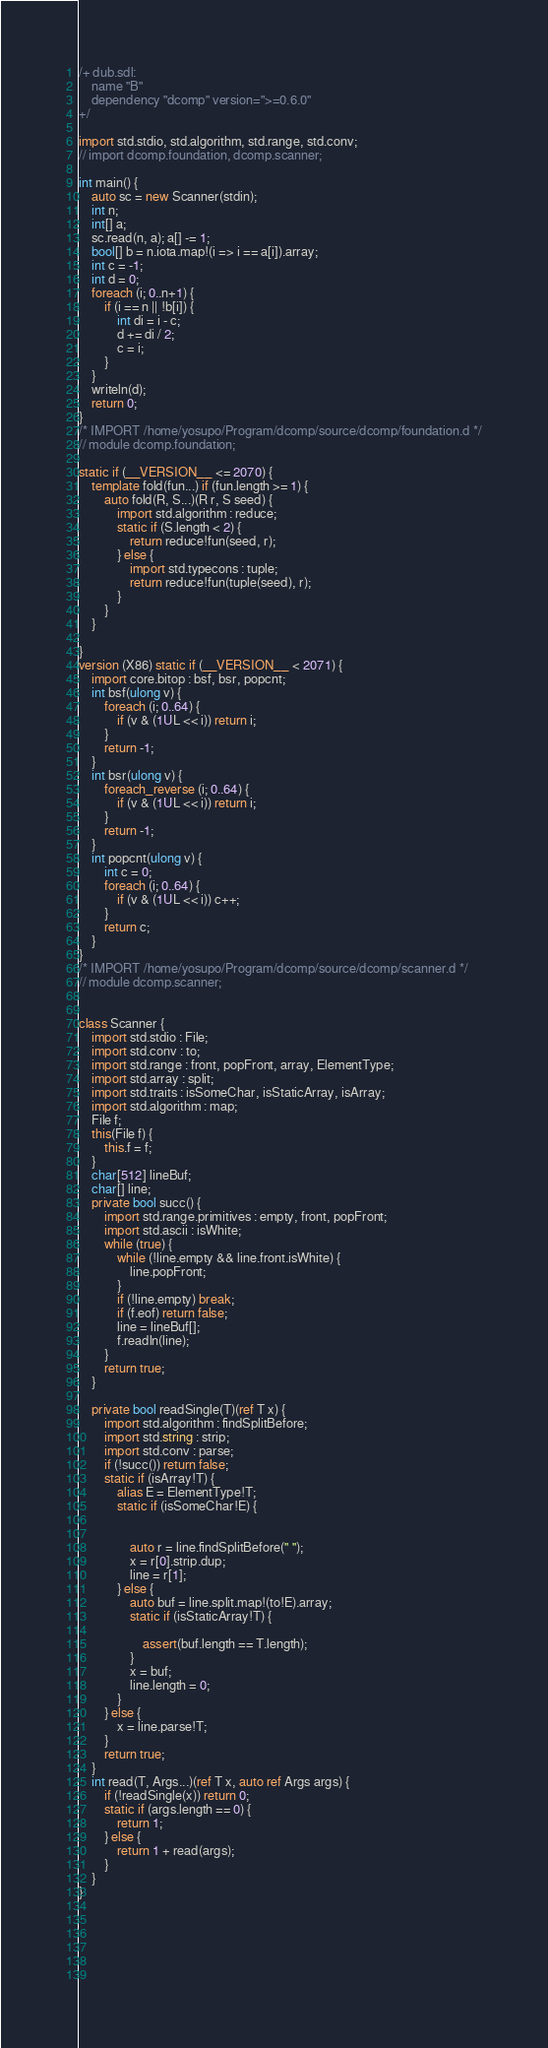Convert code to text. <code><loc_0><loc_0><loc_500><loc_500><_D_>/+ dub.sdl:
    name "B"
    dependency "dcomp" version=">=0.6.0"
+/

import std.stdio, std.algorithm, std.range, std.conv;
// import dcomp.foundation, dcomp.scanner;

int main() {
    auto sc = new Scanner(stdin);
    int n;
    int[] a;
    sc.read(n, a); a[] -= 1;
    bool[] b = n.iota.map!(i => i == a[i]).array;
    int c = -1;
    int d = 0;
    foreach (i; 0..n+1) {
        if (i == n || !b[i]) {
            int di = i - c;
            d += di / 2;
            c = i;
        }
    }
    writeln(d);
    return 0;
}
/* IMPORT /home/yosupo/Program/dcomp/source/dcomp/foundation.d */
// module dcomp.foundation;
 
static if (__VERSION__ <= 2070) {
    template fold(fun...) if (fun.length >= 1) {
        auto fold(R, S...)(R r, S seed) {
            import std.algorithm : reduce;
            static if (S.length < 2) {
                return reduce!fun(seed, r);
            } else {
                import std.typecons : tuple;
                return reduce!fun(tuple(seed), r);
            }
        }
    }
     
}
version (X86) static if (__VERSION__ < 2071) {
    import core.bitop : bsf, bsr, popcnt;
    int bsf(ulong v) {
        foreach (i; 0..64) {
            if (v & (1UL << i)) return i;
        }
        return -1;
    }
    int bsr(ulong v) {
        foreach_reverse (i; 0..64) {
            if (v & (1UL << i)) return i;
        }
        return -1;   
    }
    int popcnt(ulong v) {
        int c = 0;
        foreach (i; 0..64) {
            if (v & (1UL << i)) c++;
        }
        return c;
    }
}
/* IMPORT /home/yosupo/Program/dcomp/source/dcomp/scanner.d */
// module dcomp.scanner;

 
class Scanner {
    import std.stdio : File;
    import std.conv : to;
    import std.range : front, popFront, array, ElementType;
    import std.array : split;
    import std.traits : isSomeChar, isStaticArray, isArray; 
    import std.algorithm : map;
    File f;
    this(File f) {
        this.f = f;
    }
    char[512] lineBuf;
    char[] line;
    private bool succ() {
        import std.range.primitives : empty, front, popFront;
        import std.ascii : isWhite;
        while (true) {
            while (!line.empty && line.front.isWhite) {
                line.popFront;
            }
            if (!line.empty) break;
            if (f.eof) return false;
            line = lineBuf[];
            f.readln(line);
        }
        return true;
    }

    private bool readSingle(T)(ref T x) {
        import std.algorithm : findSplitBefore;
        import std.string : strip;
        import std.conv : parse;
        if (!succ()) return false;
        static if (isArray!T) {
            alias E = ElementType!T;
            static if (isSomeChar!E) {
                 
                 
                auto r = line.findSplitBefore(" ");
                x = r[0].strip.dup;
                line = r[1];
            } else {
                auto buf = line.split.map!(to!E).array;
                static if (isStaticArray!T) {
                     
                    assert(buf.length == T.length);
                }
                x = buf;
                line.length = 0;
            }
        } else {
            x = line.parse!T;
        }
        return true;
    }
    int read(T, Args...)(ref T x, auto ref Args args) {
        if (!readSingle(x)) return 0;
        static if (args.length == 0) {
            return 1;
        } else {
            return 1 + read(args);
        }
    }
}


 
 

 
</code> 